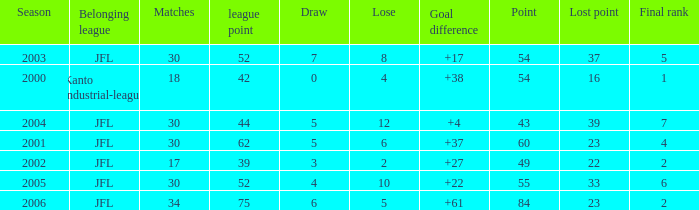I want the average lose for lost point more than 16 and goal difference less than 37 and point less than 43 None. 